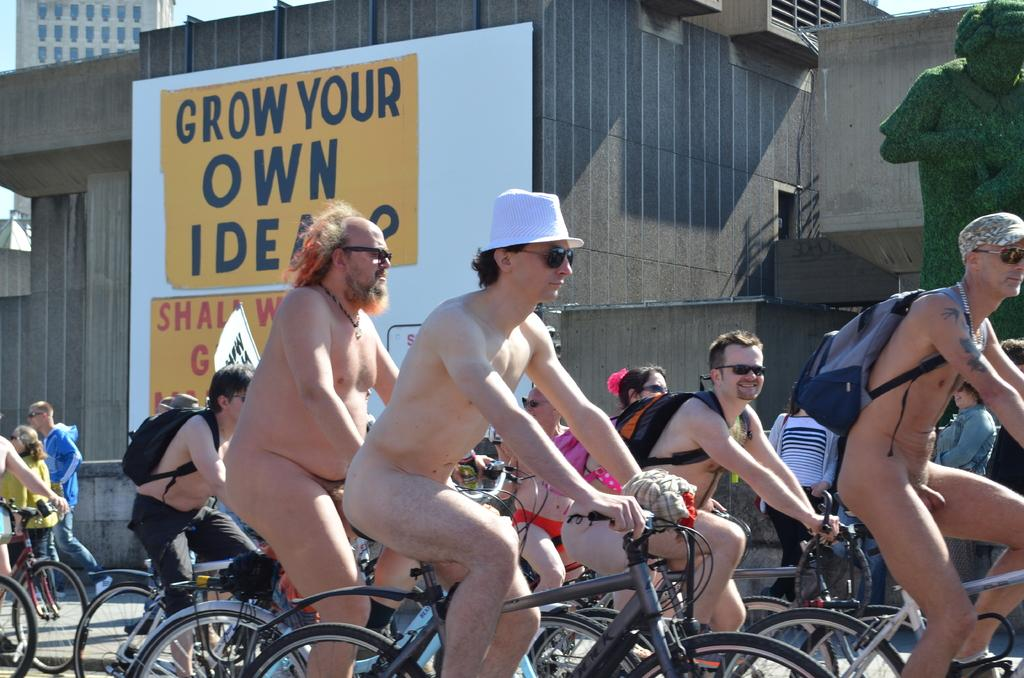How many people are in the image? There is a group of people in the image. What are the people doing in the image? The people are riding bicycles. Where are the bicycles located in the image? The bicycles are in the street. What can be seen in the background of the image? There are buildings, a tree, a hoarding, and the sky visible in the background of the image. What type of toothpaste is being advertised on the hoarding in the image? There is no toothpaste being advertised on the hoarding in the image. 